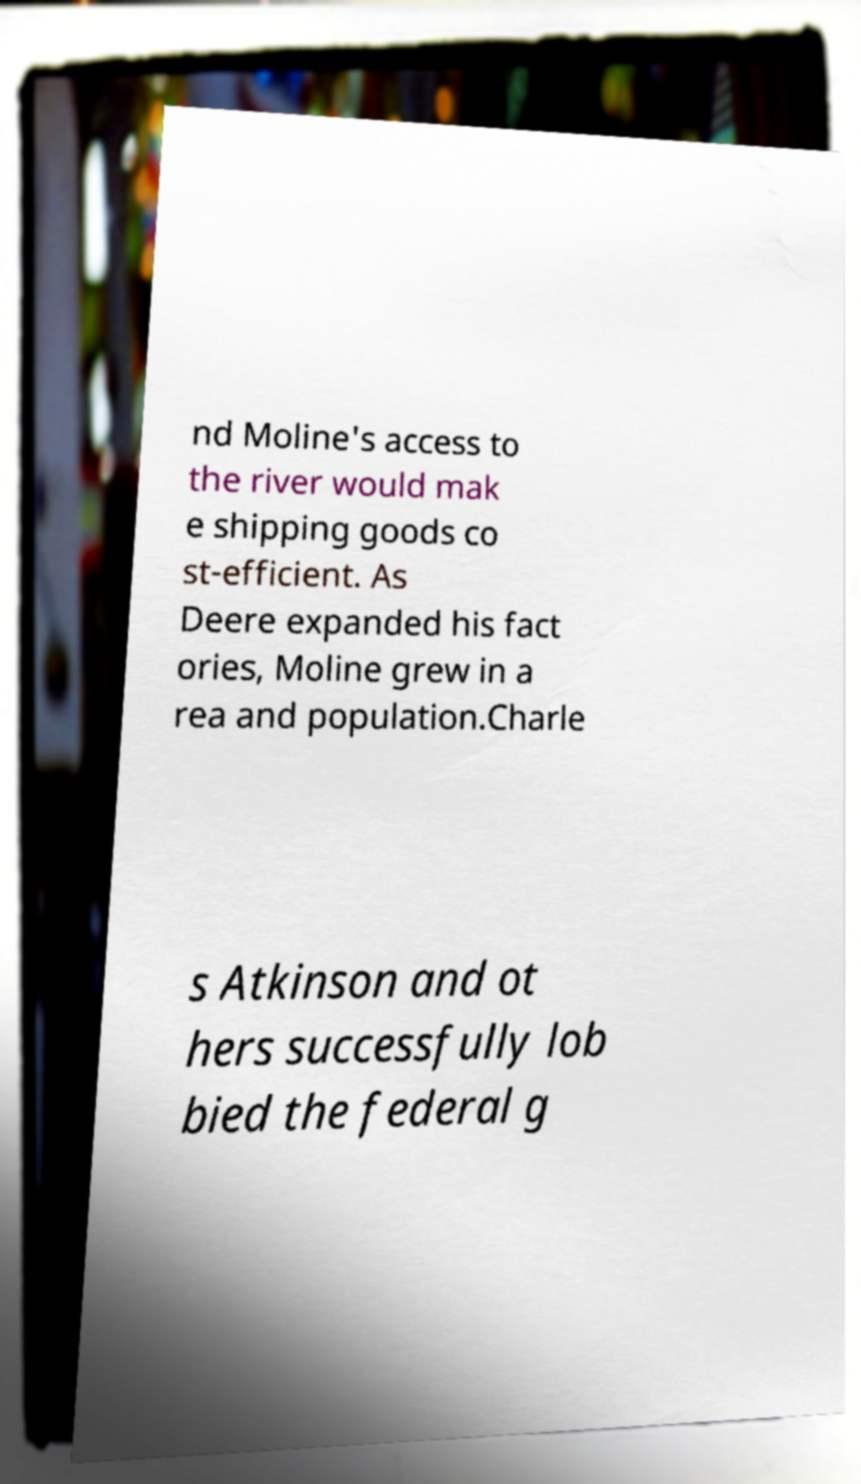I need the written content from this picture converted into text. Can you do that? nd Moline's access to the river would mak e shipping goods co st-efficient. As Deere expanded his fact ories, Moline grew in a rea and population.Charle s Atkinson and ot hers successfully lob bied the federal g 